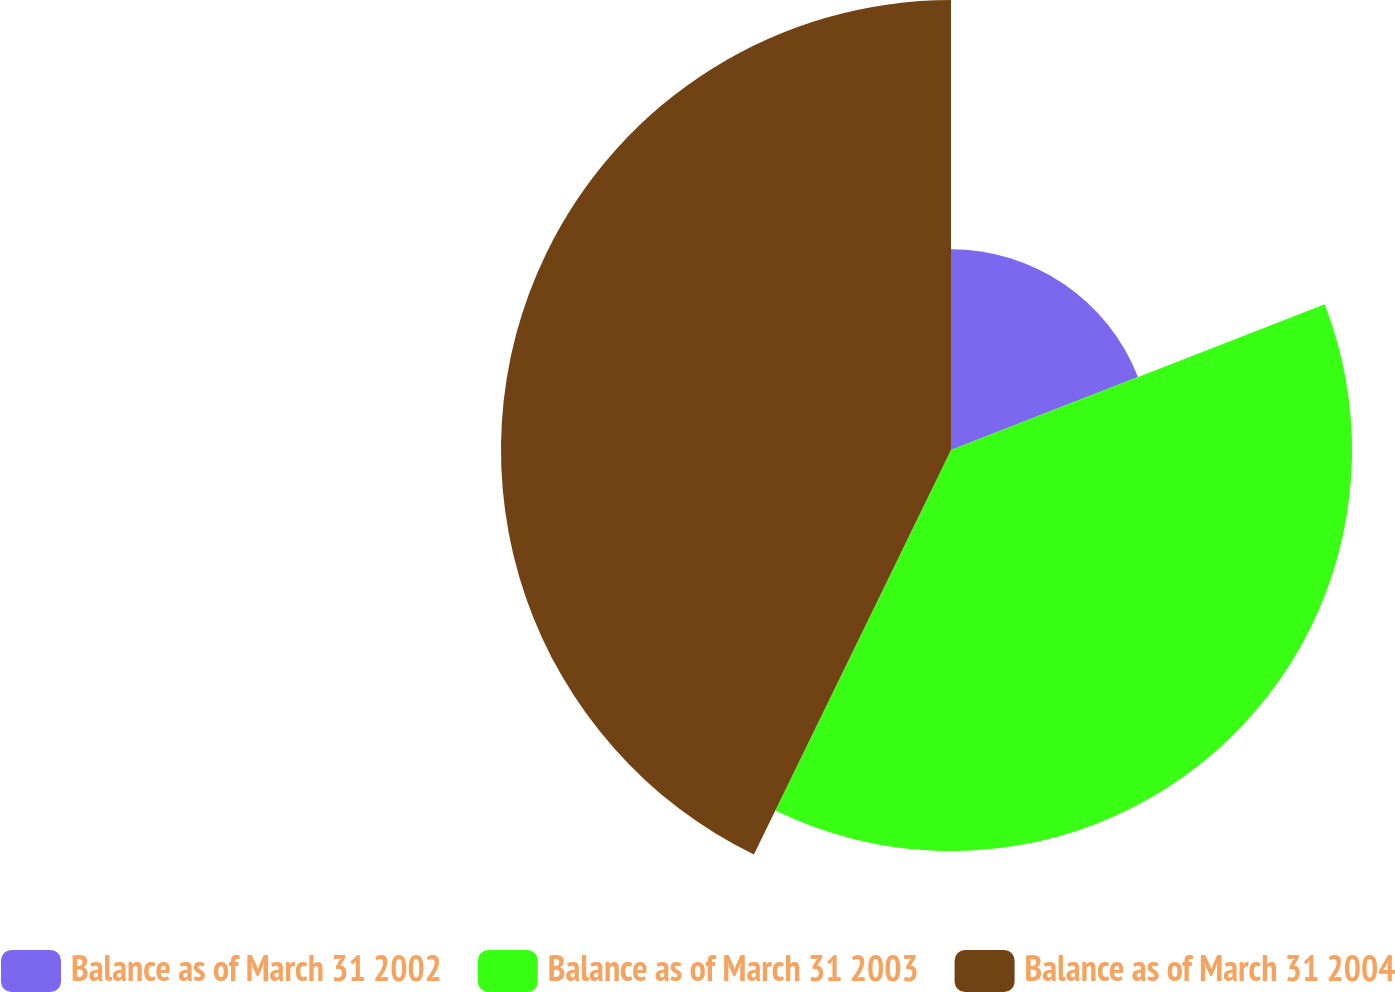<chart> <loc_0><loc_0><loc_500><loc_500><pie_chart><fcel>Balance as of March 31 2002<fcel>Balance as of March 31 2003<fcel>Balance as of March 31 2004<nl><fcel>19.08%<fcel>38.13%<fcel>42.78%<nl></chart> 